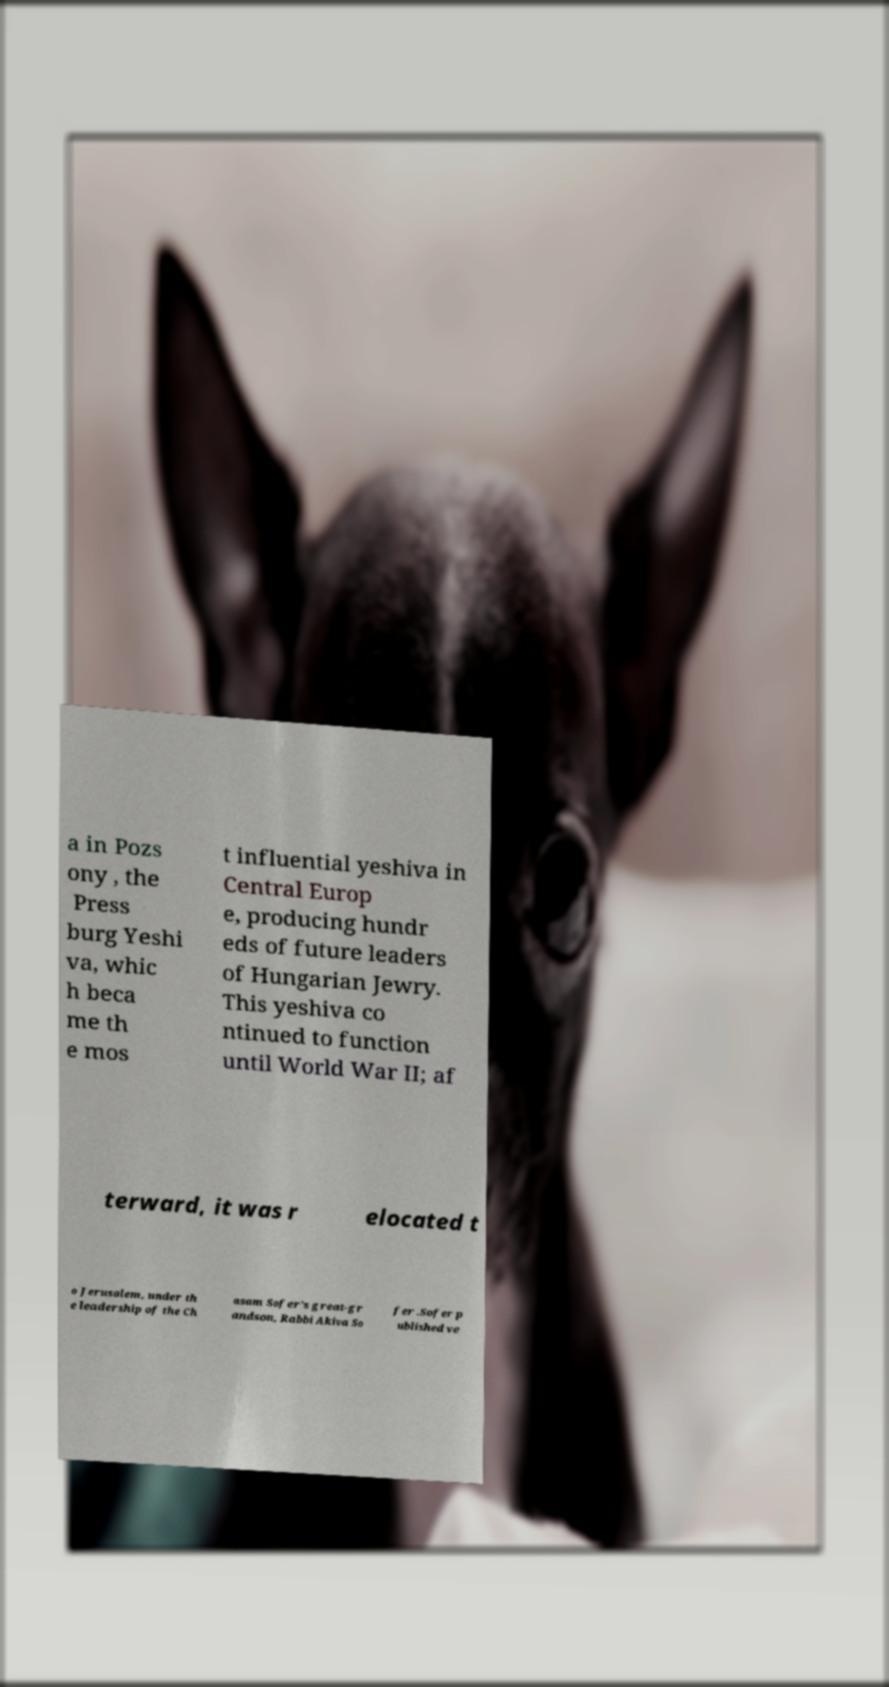Please identify and transcribe the text found in this image. a in Pozs ony , the Press burg Yeshi va, whic h beca me th e mos t influential yeshiva in Central Europ e, producing hundr eds of future leaders of Hungarian Jewry. This yeshiva co ntinued to function until World War II; af terward, it was r elocated t o Jerusalem, under th e leadership of the Ch asam Sofer's great-gr andson, Rabbi Akiva So fer .Sofer p ublished ve 